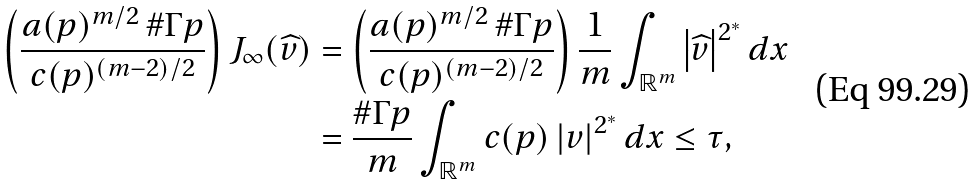<formula> <loc_0><loc_0><loc_500><loc_500>\left ( \frac { a ( p ) ^ { m / 2 } \, \# \Gamma p } { c ( p ) ^ { \left ( m - 2 \right ) / 2 } } \right ) J _ { \infty } ( \widehat { v } ) & = \left ( \frac { a ( p ) ^ { m / 2 } \, \# \Gamma p } { c ( p ) ^ { \left ( m - 2 \right ) / 2 } } \right ) \frac { 1 } { m } \int _ { \mathbb { R } ^ { m } } \left | \widehat { v } \right | ^ { 2 ^ { \ast } } d x \\ & = \frac { \# \Gamma p } { m } \int _ { \mathbb { R } ^ { m } } c ( p ) \left | v \right | ^ { 2 ^ { \ast } } d x \leq \tau ,</formula> 